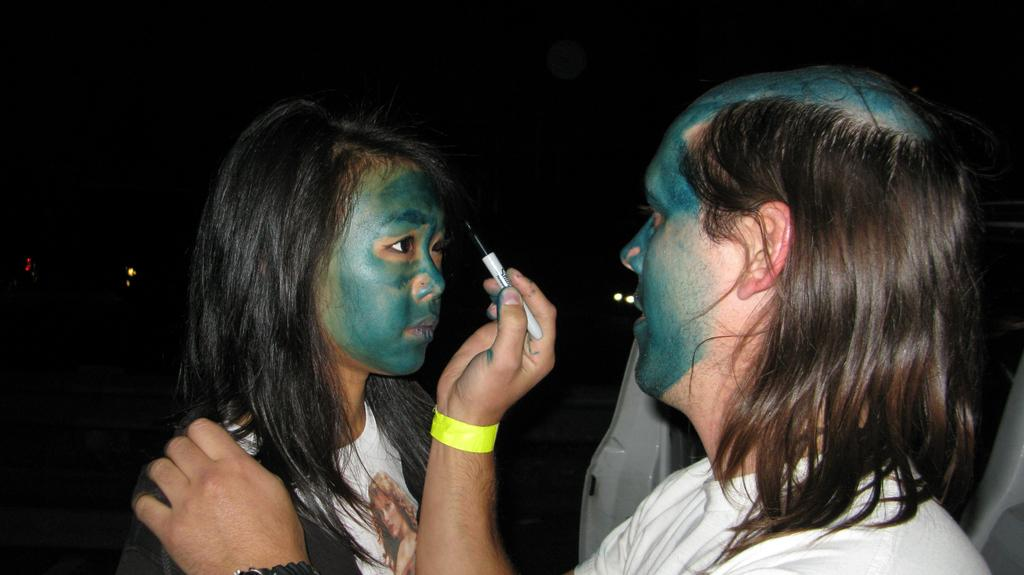What is the man doing on the right side of the image? The man is holding a sketch in his right hand. Who is present on the left side of the image? There is a woman on the left side of the image. What is a common feature on both the man's and woman's faces? There is green color paint on both the man's and woman's faces. What type of underwear is the man wearing in the image? There is no information about the man's underwear in the image, so it cannot be determined. How much sugar is visible in the image? There is no sugar present in the image. 